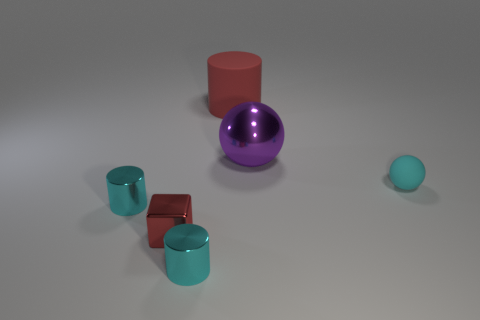Add 3 cyan metallic cylinders. How many objects exist? 9 Subtract all blocks. How many objects are left? 5 Subtract all tiny gray shiny cubes. Subtract all cylinders. How many objects are left? 3 Add 6 cyan cylinders. How many cyan cylinders are left? 8 Add 5 big gray matte blocks. How many big gray matte blocks exist? 5 Subtract 0 blue cylinders. How many objects are left? 6 